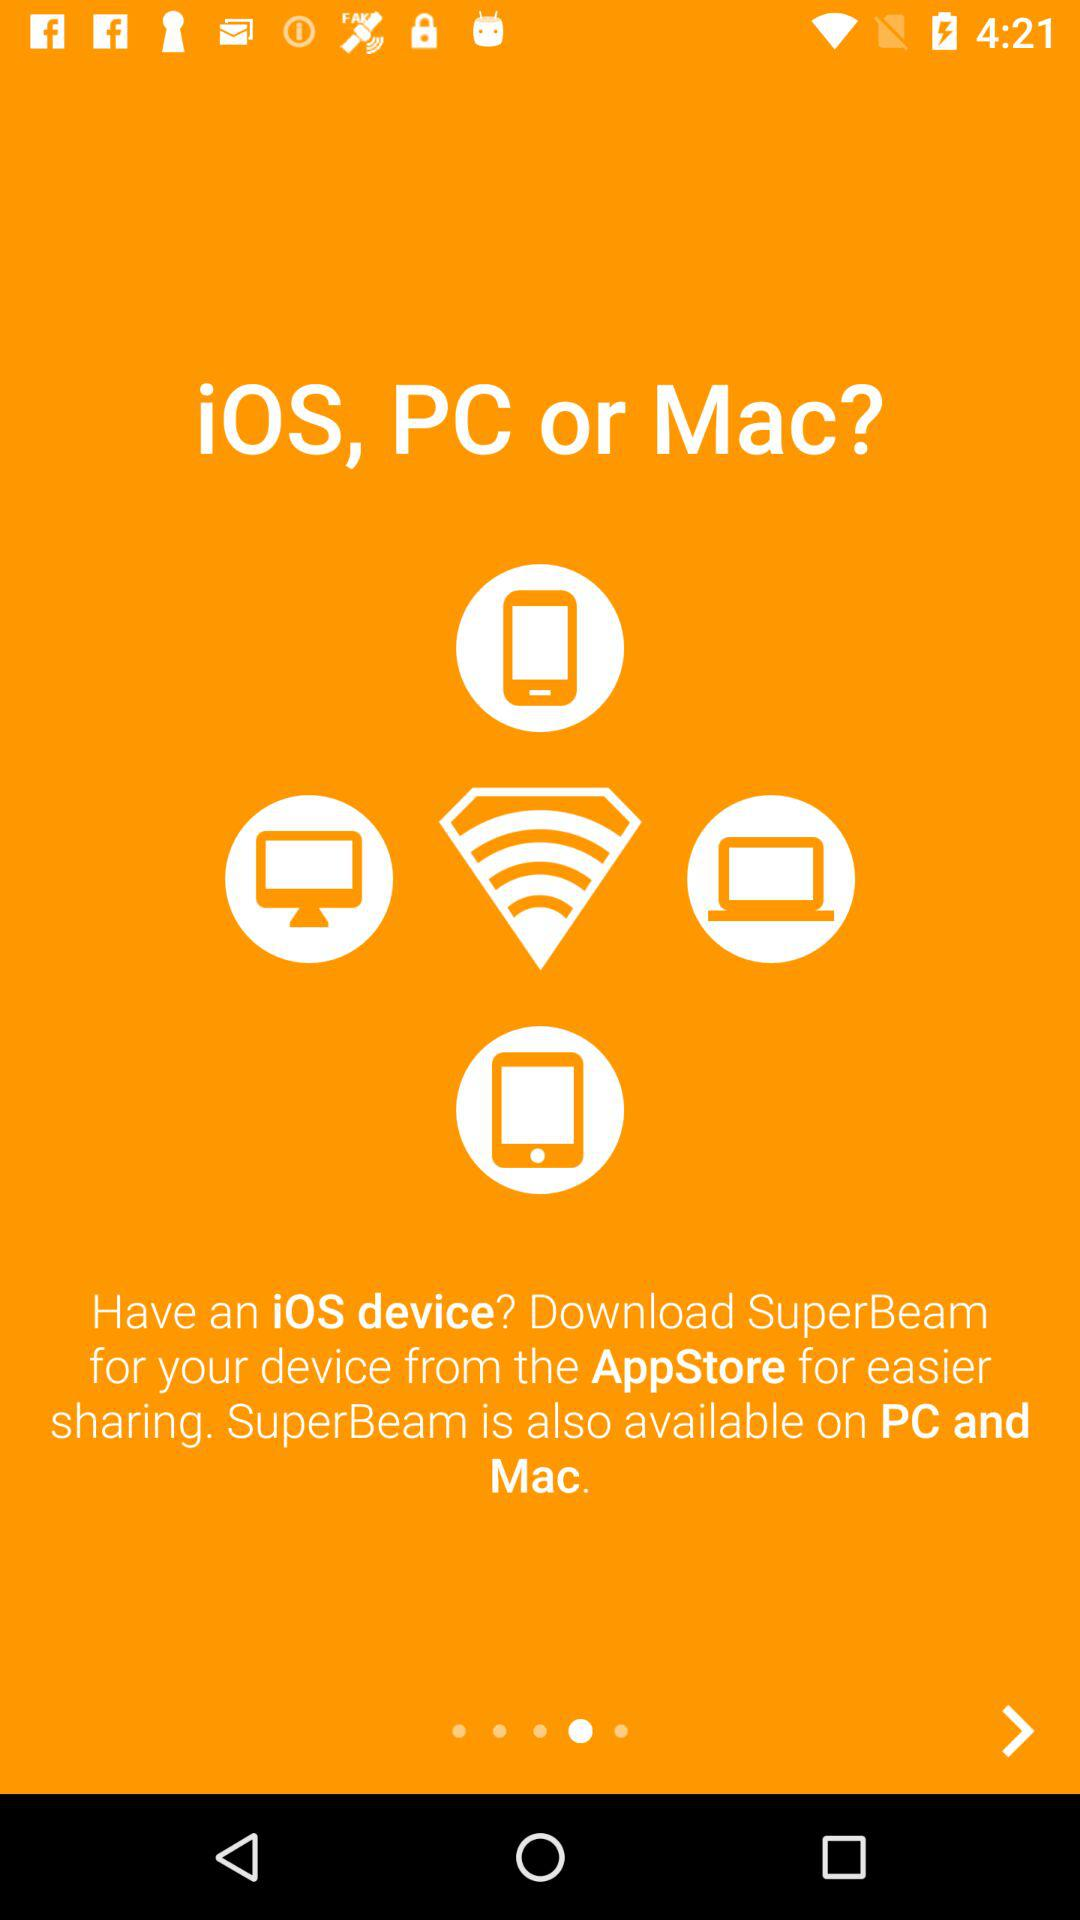From where can the application be downloaded? The application can be downloaded from the "AppStore". 